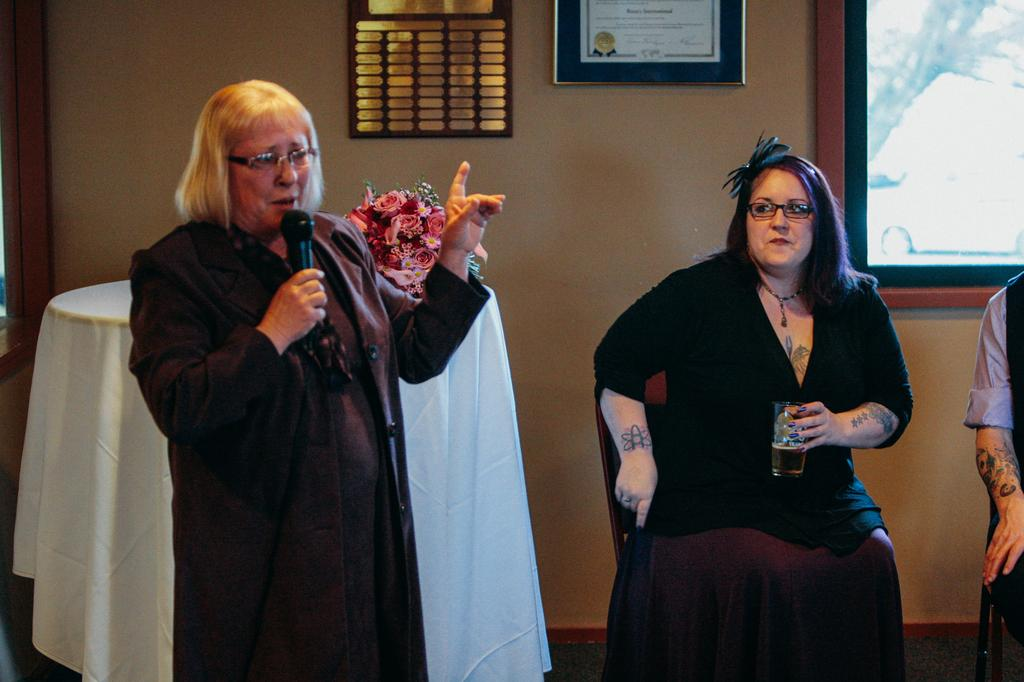Who is the main subject on the left side of the image? There is an old woman standing on the left side of the image. What is the old woman doing in the image? The old woman is speaking into a microphone. Who is the other person in the image? There is a woman sitting on the right side of the image. What is the woman wearing in the image? The woman is wearing a black dress. What type of pets can be seen in the image? There are no pets visible in the image. Can you describe the downtown area in the image? The image does not depict a downtown area; it features two women in an unspecified setting. 